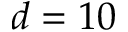<formula> <loc_0><loc_0><loc_500><loc_500>d = 1 0</formula> 